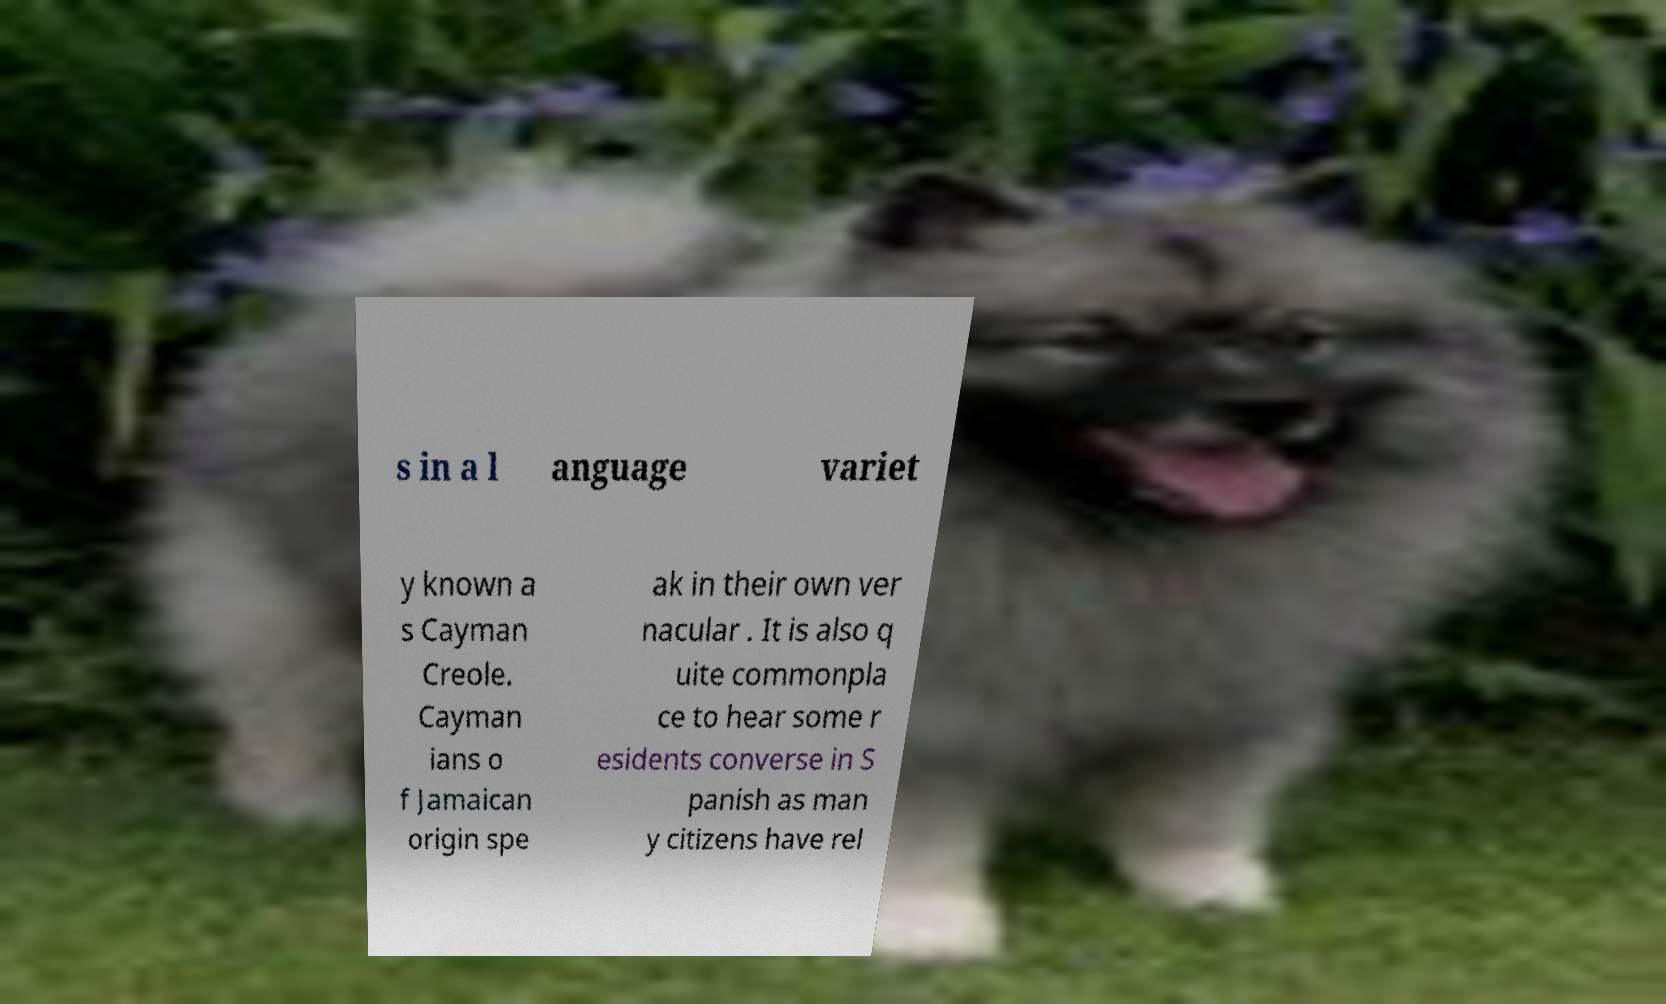Please read and relay the text visible in this image. What does it say? s in a l anguage variet y known a s Cayman Creole. Cayman ians o f Jamaican origin spe ak in their own ver nacular . It is also q uite commonpla ce to hear some r esidents converse in S panish as man y citizens have rel 